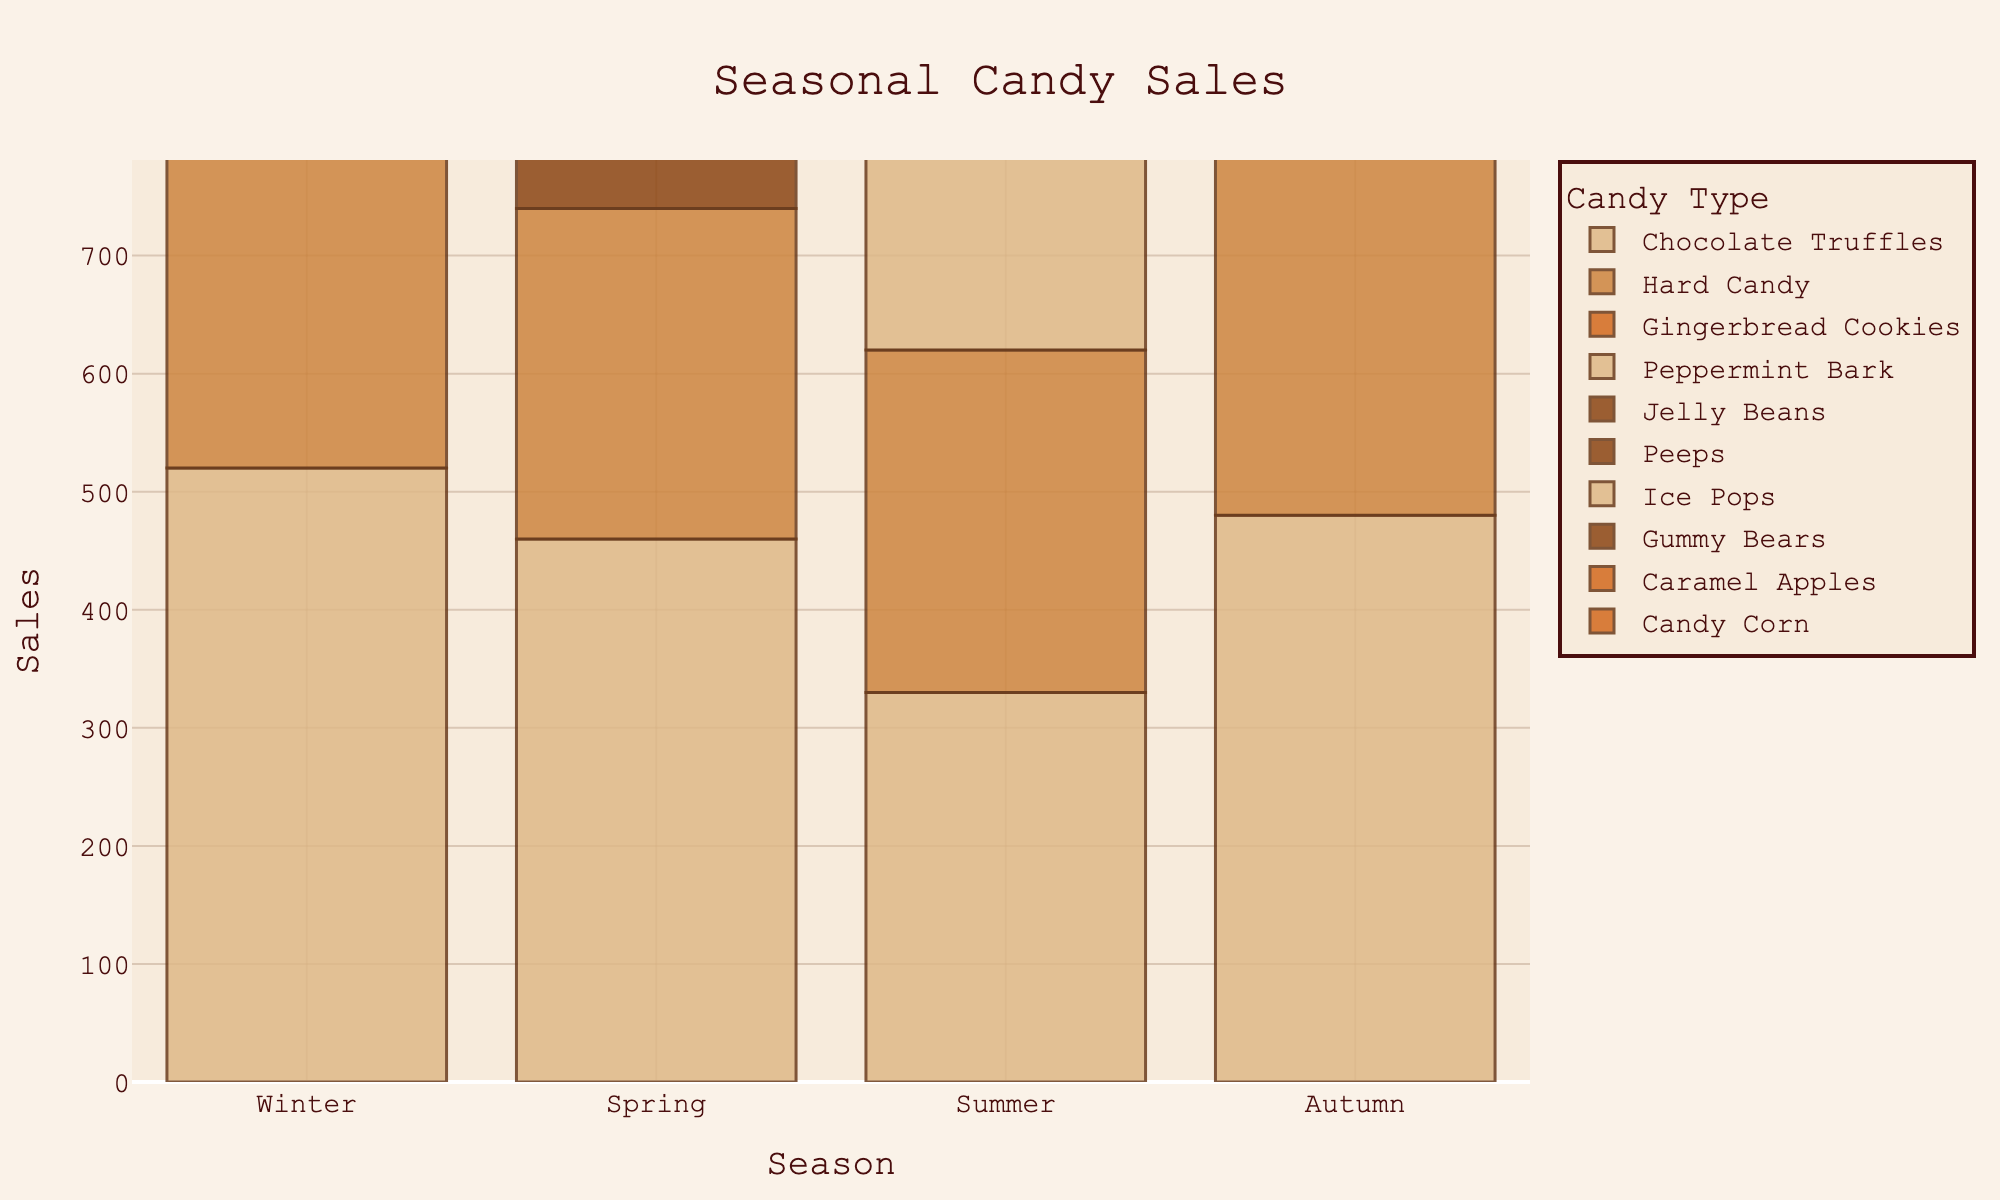Which season has the highest sales of Chocolate Truffles? By looking at the lengths of the bars for Chocolate Truffles across each season, Winter shows the highest bar height, indicating the highest sales.
Answer: Winter Which candy type has the lowest sales in Summer? By comparing the lengths of the bars for each candy type in the Summer section, Hard Candy has the shortest bar.
Answer: Hard Candy Among all the seasons, which candy type has its highest sales in Autumn? By looking at the bars specific to each candy type across the seasons, Candy Corn has its highest sales in Autumn.
Answer: Candy Corn What is the total sales for Hard Candy across all seasons? Add the sales numbers for Hard Candy from each season: 340 (Winter) + 280 (Spring) + 290 (Summer) + 370 (Autumn), which totals to 1280.
Answer: 1280 How do the sales of Jelly Beans in Spring compare to the sales of Ice Pops in Summer? Compare the lengths of the Jelly Beans bar in Spring and the Ice Pops bar in Summer. Ice Pops have a longer bar, indicating higher sales.
Answer: Ice Pops have higher sales Which season has the greatest variety of candy types with noticeable sales? Count the number of unique candy types with bars in each season. Winter and Spring both show four different types, while Summer and Autumn also show four different types but Summer's bars are relatively more varied in length which might give more insights.
Answer: Summer What are the combined sales of Peppermint Bark and Gingerbread Cookies in Winter? Add the sales of Peppermint Bark (610) and Gingerbread Cookies (450) for Winter: 610 + 450 = 1060.
Answer: 1060 If you sum the sales of all candy types for Spring, which candy type has sales closest to this sum? First, find the sum of all candy types in Spring: 460 (Chocolate Truffles) + 280 (Hard Candy) + 590 (Jelly Beans) + 540 (Peeps) = 1870. Then, look for the candy type with sales closest to this number. None of the individual sales match closely, indicating all are much lower.
Answer: None close How do the sales of Chocolate Truffles change throughout the seasons? Observe the bar heights for Chocolate Truffles across all seasons: Winter (520) shows the highest, Spring (460) drops slightly, Summer (330) shows a significant drop, and Autumn (480) rises again.
Answer: Highest in Winter, drops in Summer, rises in Autumn Which candy type shows the most consistent sales across all seasons? By observing the lengths of the bars, Hard Candy has more consistent bar heights across all seasons (Winter 340, Spring 280, Summer 290, Autumn 370) than other candy types.
Answer: Hard Candy 